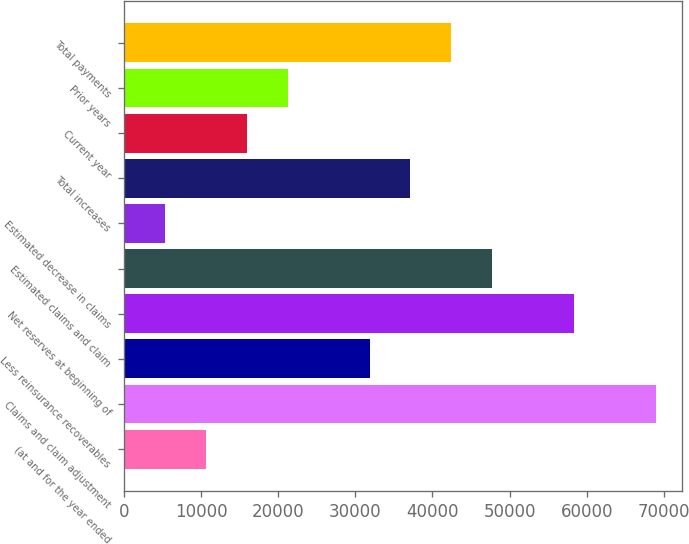Convert chart to OTSL. <chart><loc_0><loc_0><loc_500><loc_500><bar_chart><fcel>(at and for the year ended<fcel>Claims and claim adjustment<fcel>Less reinsurance recoverables<fcel>Net reserves at beginning of<fcel>Estimated claims and claim<fcel>Estimated decrease in claims<fcel>Total increases<fcel>Current year<fcel>Prior years<fcel>Total payments<nl><fcel>10630<fcel>68963<fcel>31842<fcel>58357<fcel>47751<fcel>5327<fcel>37145<fcel>15933<fcel>21236<fcel>42448<nl></chart> 